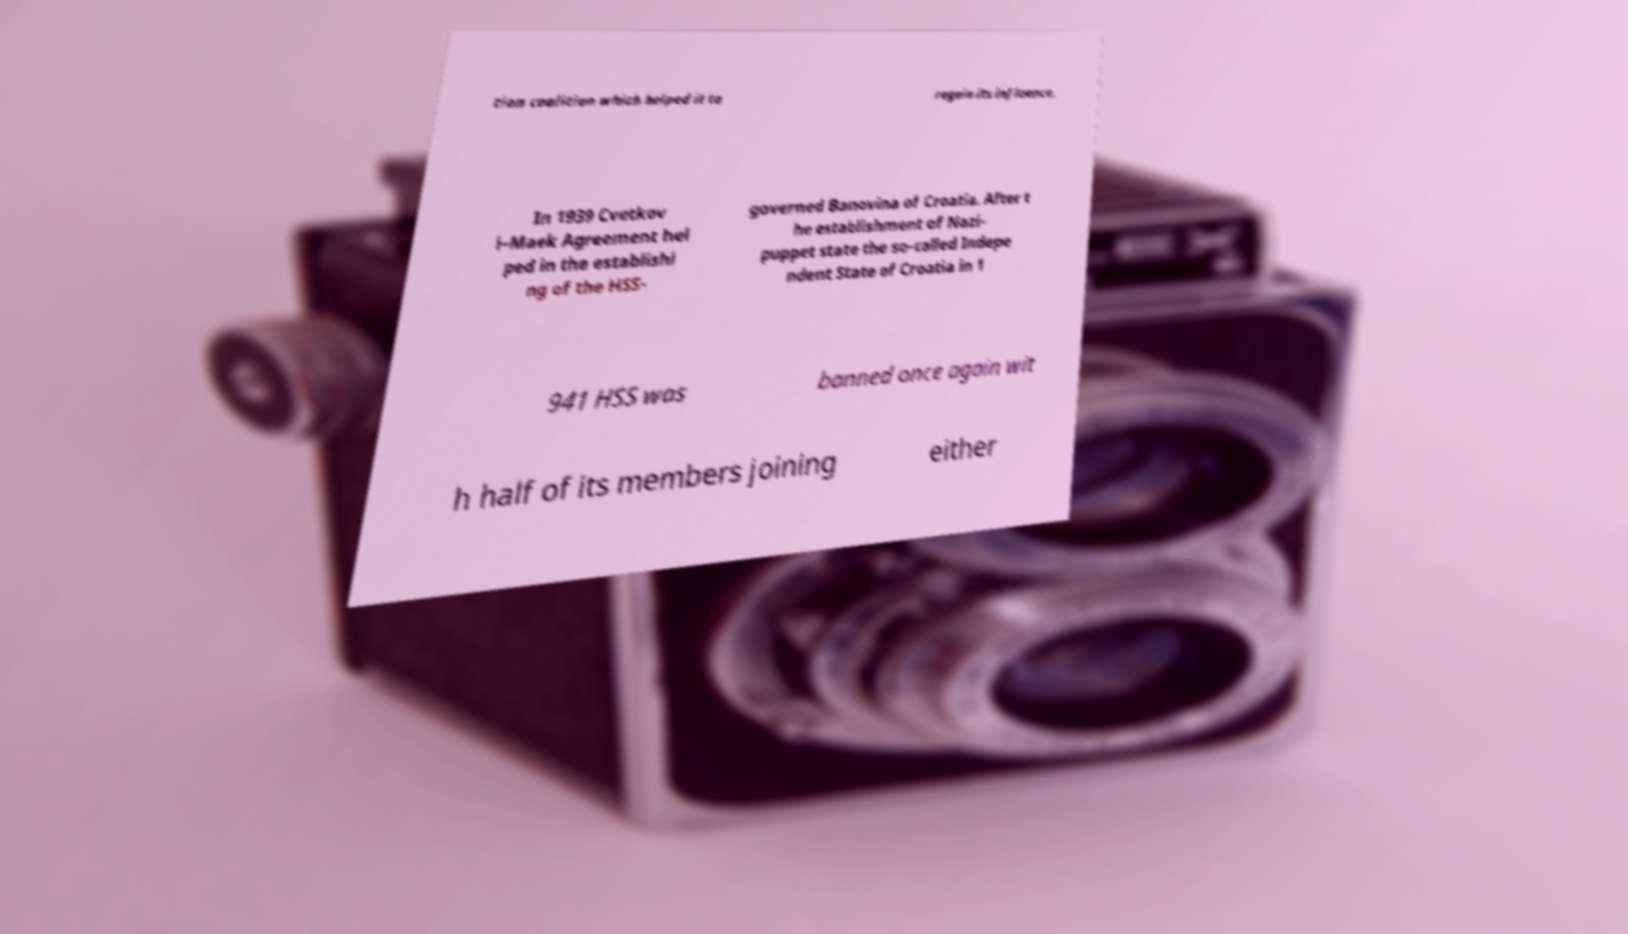Please read and relay the text visible in this image. What does it say? tion coalition which helped it to regain its influence. In 1939 Cvetkov i–Maek Agreement hel ped in the establishi ng of the HSS- governed Banovina of Croatia. After t he establishment of Nazi- puppet state the so-called Indepe ndent State of Croatia in 1 941 HSS was banned once again wit h half of its members joining either 